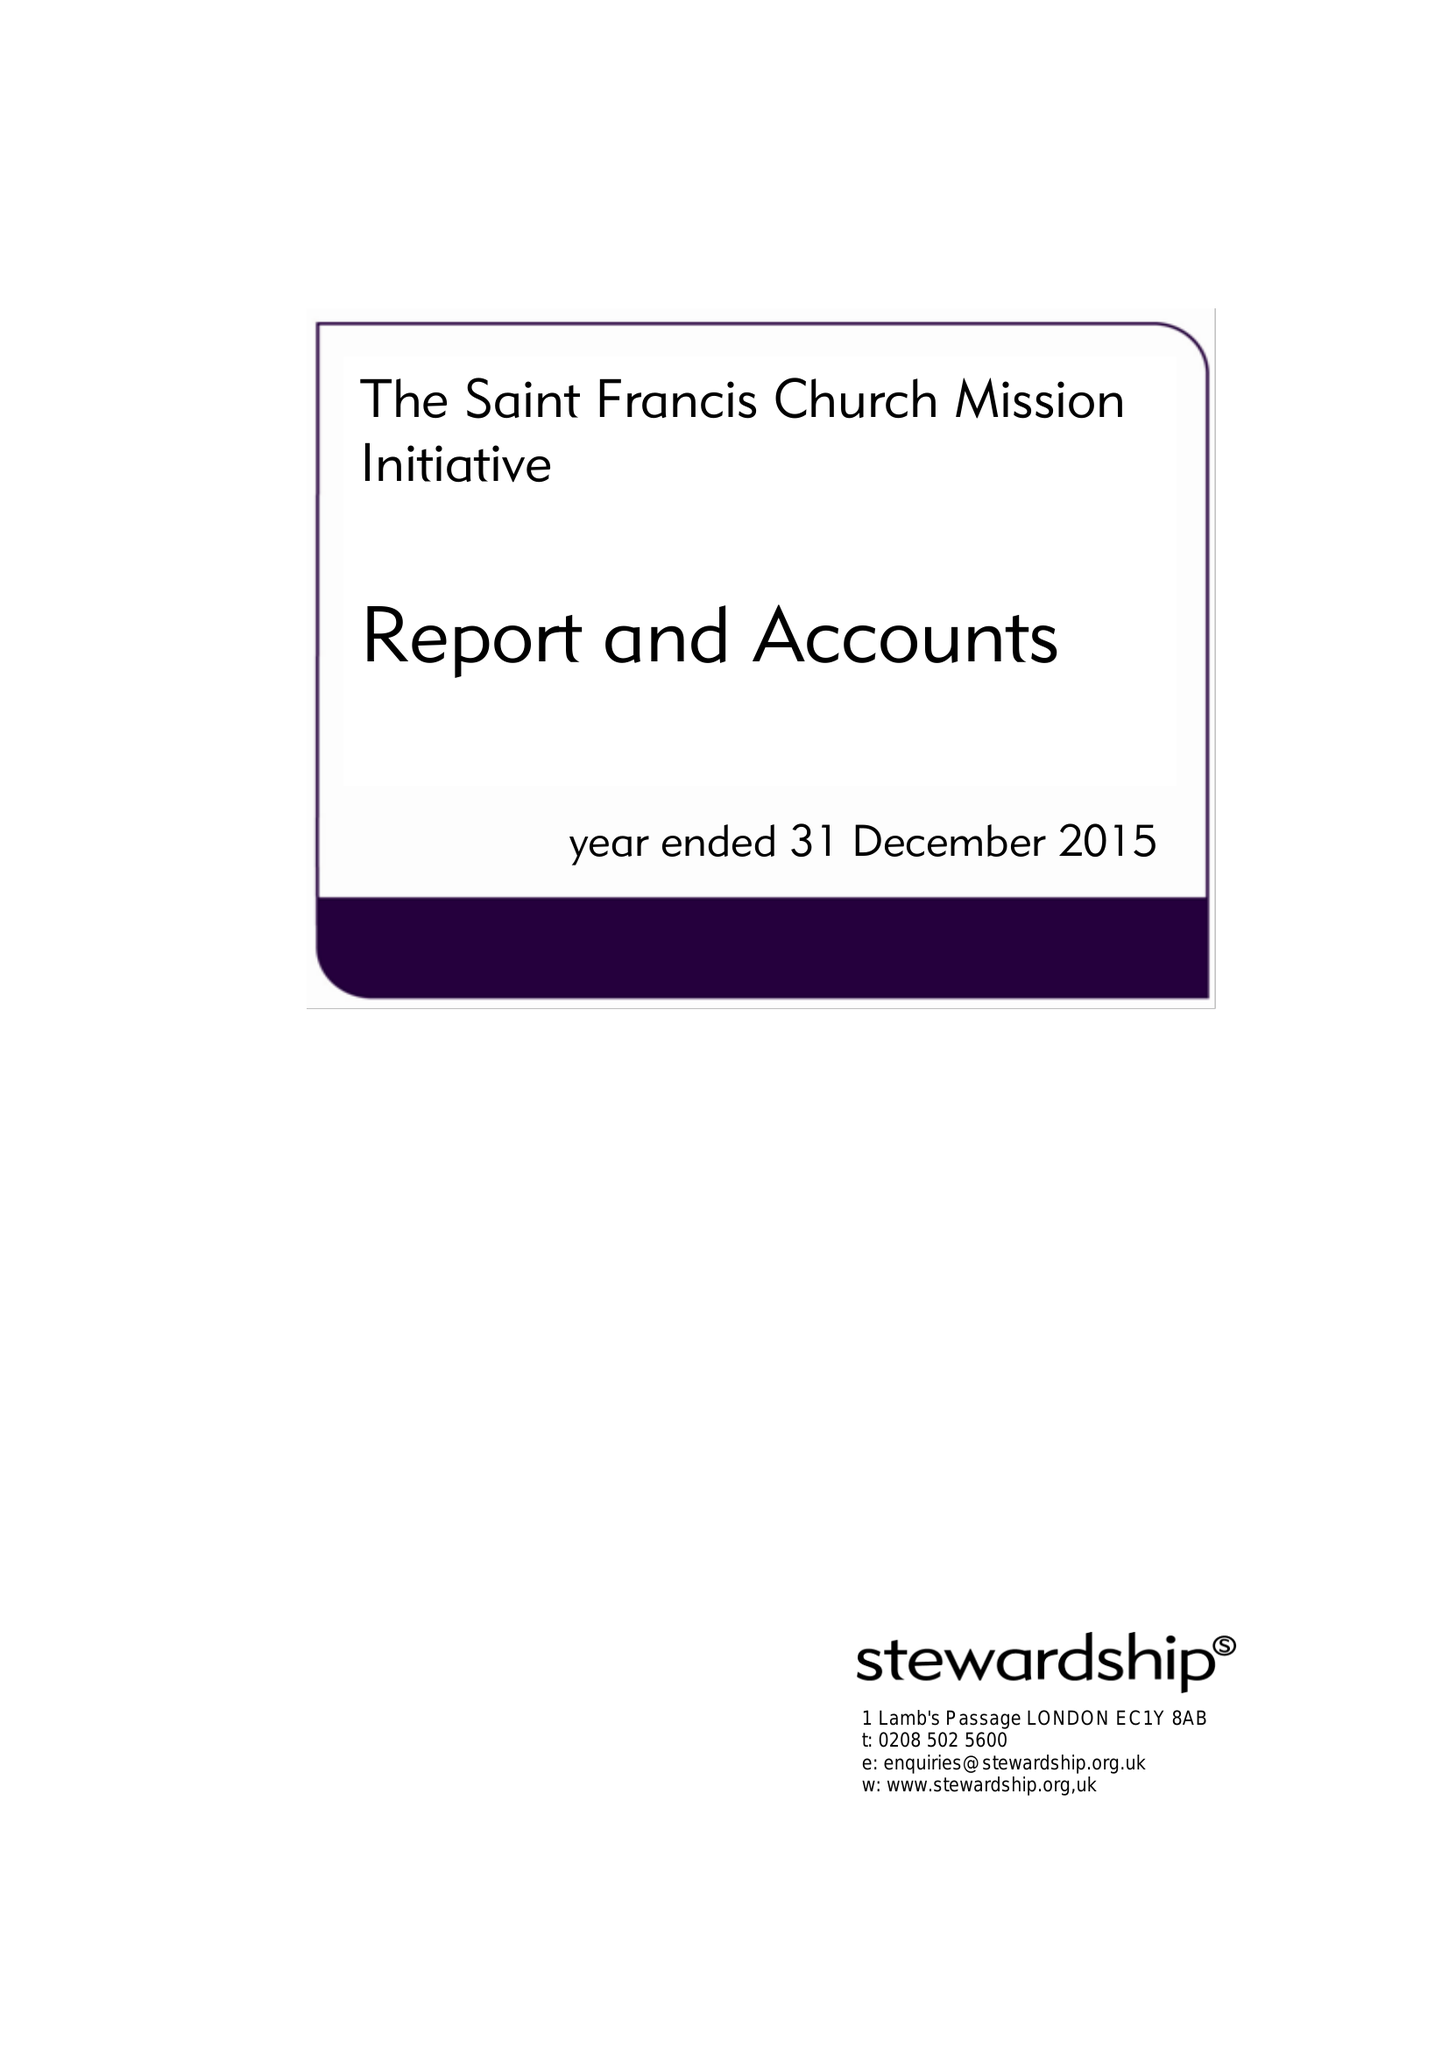What is the value for the report_date?
Answer the question using a single word or phrase. 2015-12-31 